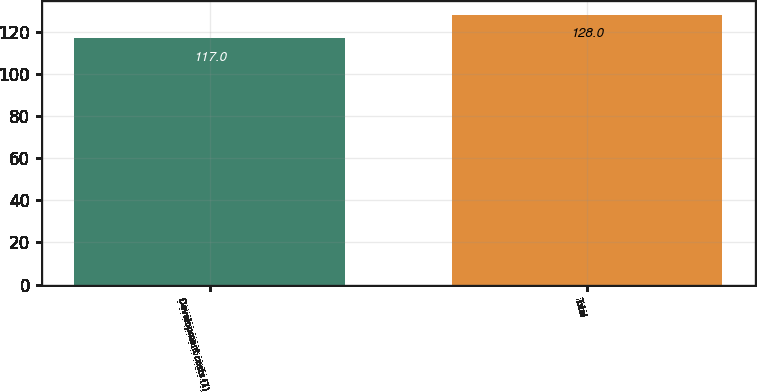<chart> <loc_0><loc_0><loc_500><loc_500><bar_chart><fcel>Development costs (1)<fcel>Total<nl><fcel>117<fcel>128<nl></chart> 